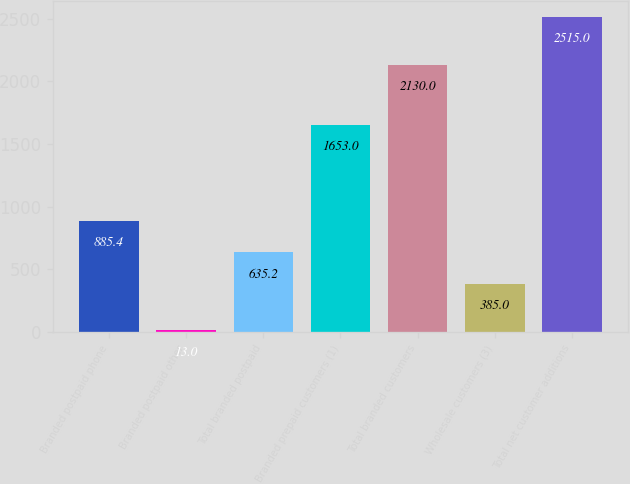Convert chart to OTSL. <chart><loc_0><loc_0><loc_500><loc_500><bar_chart><fcel>Branded postpaid phone<fcel>Branded postpaid other<fcel>Total branded postpaid<fcel>Branded prepaid customers (1)<fcel>Total branded customers<fcel>Wholesale customers (3)<fcel>Total net customer additions<nl><fcel>885.4<fcel>13<fcel>635.2<fcel>1653<fcel>2130<fcel>385<fcel>2515<nl></chart> 